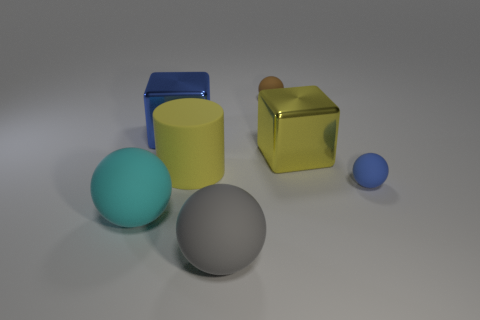Add 1 tiny blue matte things. How many objects exist? 8 Subtract all cubes. How many objects are left? 5 Subtract 0 red spheres. How many objects are left? 7 Subtract all brown objects. Subtract all blue shiny blocks. How many objects are left? 5 Add 6 brown matte things. How many brown matte things are left? 7 Add 5 big gray shiny cubes. How many big gray shiny cubes exist? 5 